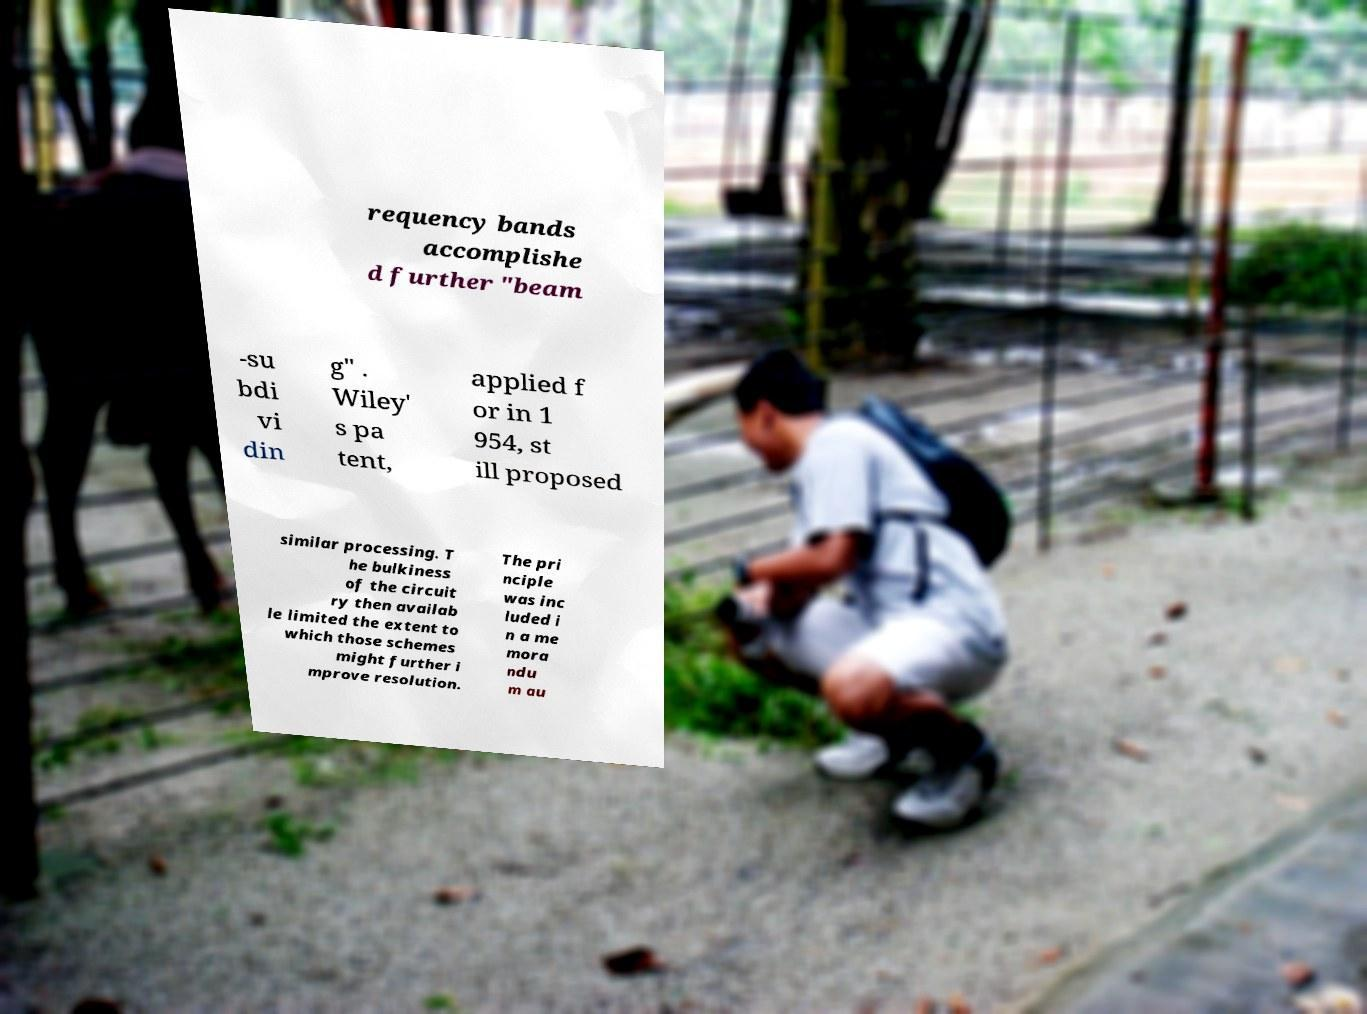Could you extract and type out the text from this image? requency bands accomplishe d further "beam -su bdi vi din g" . Wiley' s pa tent, applied f or in 1 954, st ill proposed similar processing. T he bulkiness of the circuit ry then availab le limited the extent to which those schemes might further i mprove resolution. The pri nciple was inc luded i n a me mora ndu m au 